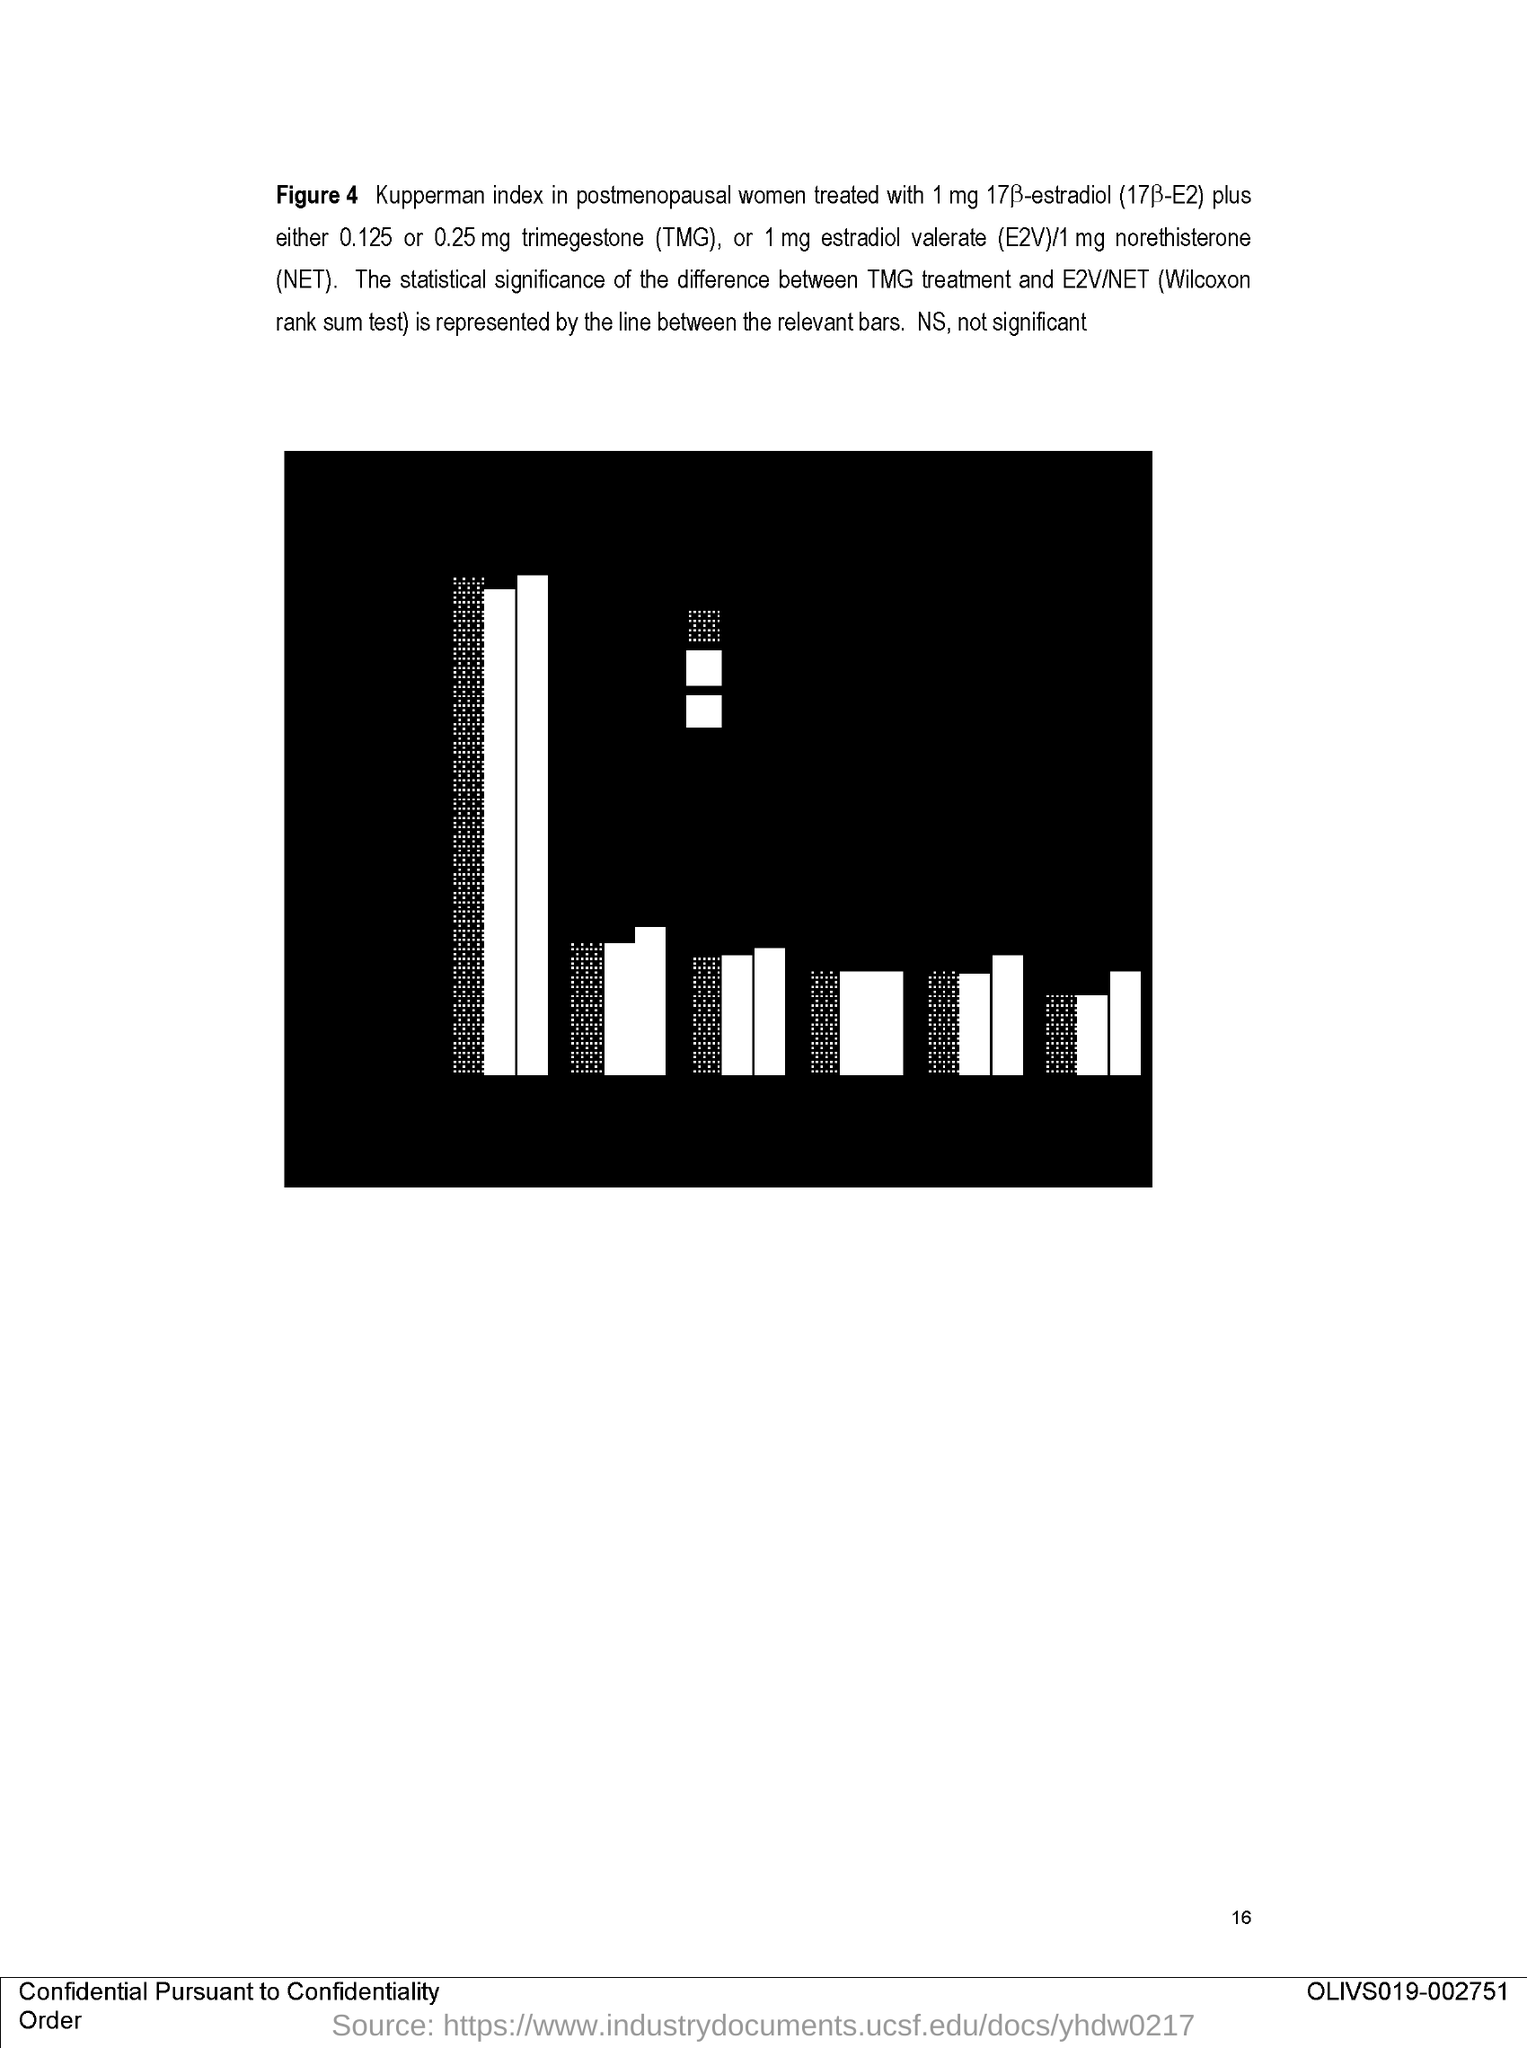Outline some significant characteristics in this image. The Wilcoxon rank sum test is the name of the E2V/NET test. Trimegestone, also known as TMG, is a chemical compound with the expansion of "What is the expansion of TMG? trimegestone.. NET is an abbreviation that stands for norethisterone. It is a synthetic progestogen hormone that is used in the treatment of a variety of conditions, including menstrual disorders and reproductive health issues. The recommended dosage of norethisterone for treatment is 1mg. The figure number of the bar graph is 4. 